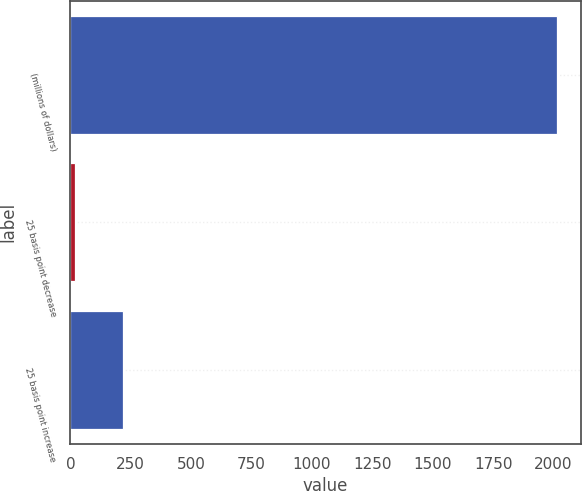Convert chart to OTSL. <chart><loc_0><loc_0><loc_500><loc_500><bar_chart><fcel>(millions of dollars)<fcel>25 basis point decrease<fcel>25 basis point increase<nl><fcel>2013<fcel>18.6<fcel>218.04<nl></chart> 